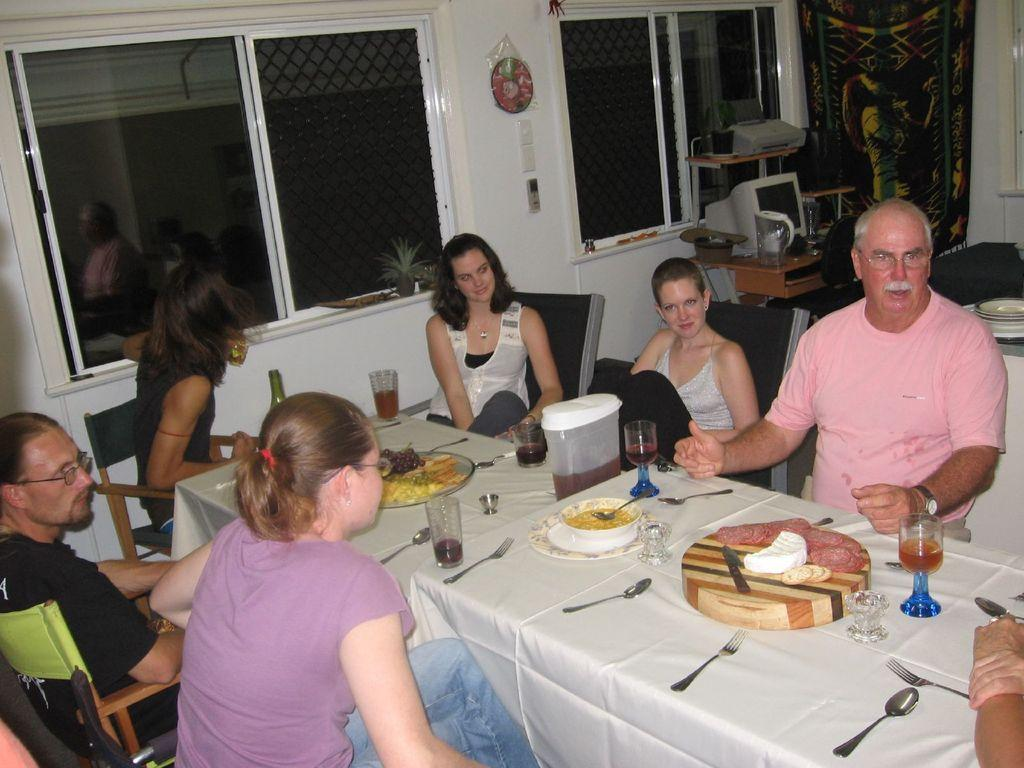How many people are in the image? There is a group of persons in the image. What are the persons doing in the image? The persons are sitting on chairs and having their food and drinks. What can be seen at the top of the image? There are windows visible at the top of the image. How many frogs are sitting on the chairs with the persons in the image? There are no frogs present in the image; only the group of persons is visible. What type of control is being used by the persons to manage their food and drinks? There is no control device visible in the image; the persons are simply eating and drinking. 